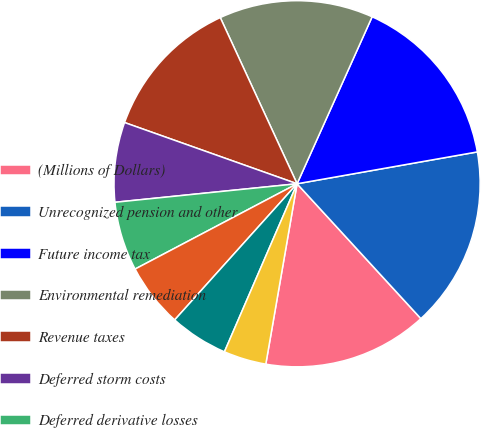Convert chart to OTSL. <chart><loc_0><loc_0><loc_500><loc_500><pie_chart><fcel>(Millions of Dollars)<fcel>Unrecognized pension and other<fcel>Future income tax<fcel>Environmental remediation<fcel>Revenue taxes<fcel>Deferred storm costs<fcel>Deferred derivative losses<fcel>Unamortized loss on reacquired<fcel>Recoverable energy costs<fcel>Pension and other<nl><fcel>14.55%<fcel>15.96%<fcel>15.49%<fcel>13.61%<fcel>12.68%<fcel>7.04%<fcel>6.1%<fcel>5.63%<fcel>5.16%<fcel>3.76%<nl></chart> 